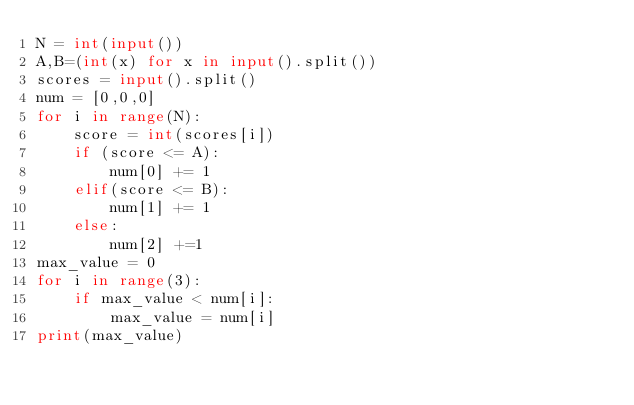<code> <loc_0><loc_0><loc_500><loc_500><_Python_>N = int(input())
A,B=(int(x) for x in input().split())
scores = input().split()
num = [0,0,0]
for i in range(N):
    score = int(scores[i])
    if (score <= A):
        num[0] += 1
    elif(score <= B):
        num[1] += 1
    else:
        num[2] +=1
max_value = 0
for i in range(3):
    if max_value < num[i]:
        max_value = num[i]
print(max_value)</code> 